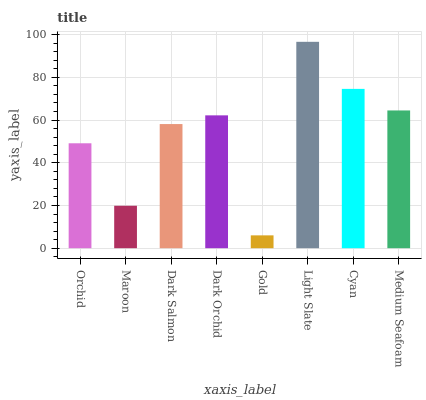Is Maroon the minimum?
Answer yes or no. No. Is Maroon the maximum?
Answer yes or no. No. Is Orchid greater than Maroon?
Answer yes or no. Yes. Is Maroon less than Orchid?
Answer yes or no. Yes. Is Maroon greater than Orchid?
Answer yes or no. No. Is Orchid less than Maroon?
Answer yes or no. No. Is Dark Orchid the high median?
Answer yes or no. Yes. Is Dark Salmon the low median?
Answer yes or no. Yes. Is Gold the high median?
Answer yes or no. No. Is Light Slate the low median?
Answer yes or no. No. 